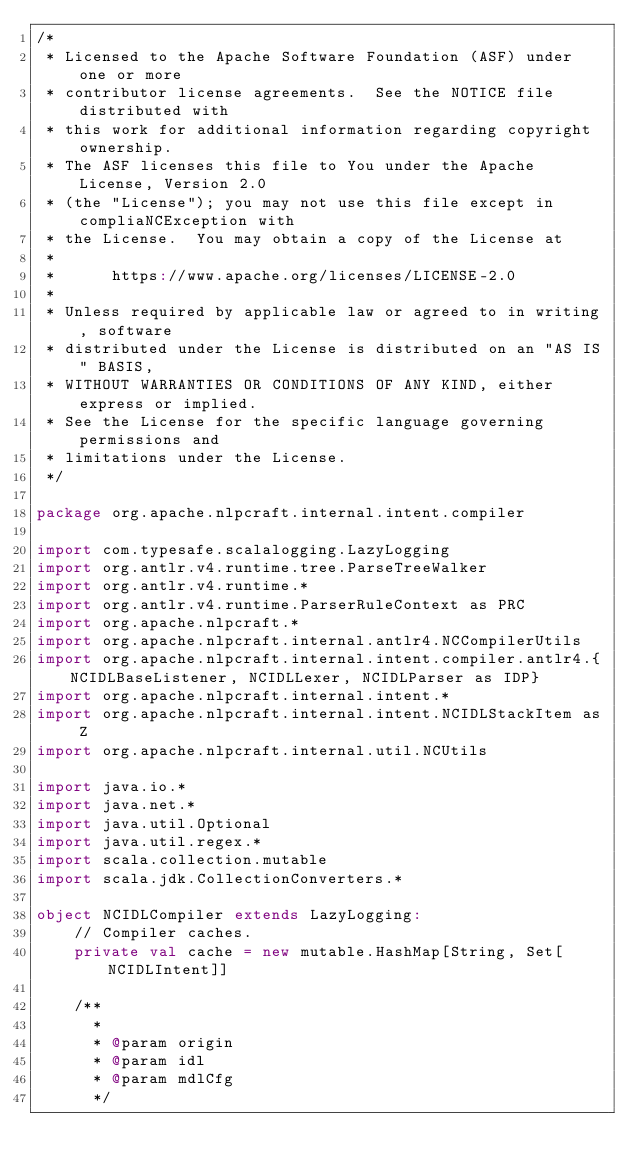Convert code to text. <code><loc_0><loc_0><loc_500><loc_500><_Scala_>/*
 * Licensed to the Apache Software Foundation (ASF) under one or more
 * contributor license agreements.  See the NOTICE file distributed with
 * this work for additional information regarding copyright ownership.
 * The ASF licenses this file to You under the Apache License, Version 2.0
 * (the "License"); you may not use this file except in compliaNCException with
 * the License.  You may obtain a copy of the License at
 *
 *      https://www.apache.org/licenses/LICENSE-2.0
 *
 * Unless required by applicable law or agreed to in writing, software
 * distributed under the License is distributed on an "AS IS" BASIS,
 * WITHOUT WARRANTIES OR CONDITIONS OF ANY KIND, either express or implied.
 * See the License for the specific language governing permissions and
 * limitations under the License.
 */

package org.apache.nlpcraft.internal.intent.compiler

import com.typesafe.scalalogging.LazyLogging
import org.antlr.v4.runtime.tree.ParseTreeWalker
import org.antlr.v4.runtime.*
import org.antlr.v4.runtime.ParserRuleContext as PRC
import org.apache.nlpcraft.*
import org.apache.nlpcraft.internal.antlr4.NCCompilerUtils
import org.apache.nlpcraft.internal.intent.compiler.antlr4.{NCIDLBaseListener, NCIDLLexer, NCIDLParser as IDP}
import org.apache.nlpcraft.internal.intent.*
import org.apache.nlpcraft.internal.intent.NCIDLStackItem as Z
import org.apache.nlpcraft.internal.util.NCUtils

import java.io.*
import java.net.*
import java.util.Optional
import java.util.regex.*
import scala.collection.mutable
import scala.jdk.CollectionConverters.*

object NCIDLCompiler extends LazyLogging:
    // Compiler caches.
    private val cache = new mutable.HashMap[String, Set[NCIDLIntent]]

    /**
      *
      * @param origin
      * @param idl
      * @param mdlCfg
      */</code> 